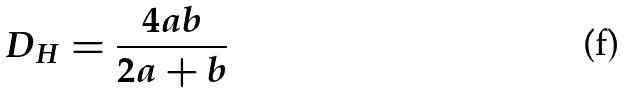<formula> <loc_0><loc_0><loc_500><loc_500>D _ { H } = \frac { 4 a b } { 2 a + b }</formula> 